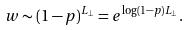<formula> <loc_0><loc_0><loc_500><loc_500>w \sim ( 1 - p ) ^ { L _ { \bot } } = e ^ { \log ( 1 - p ) L _ { \bot } } .</formula> 